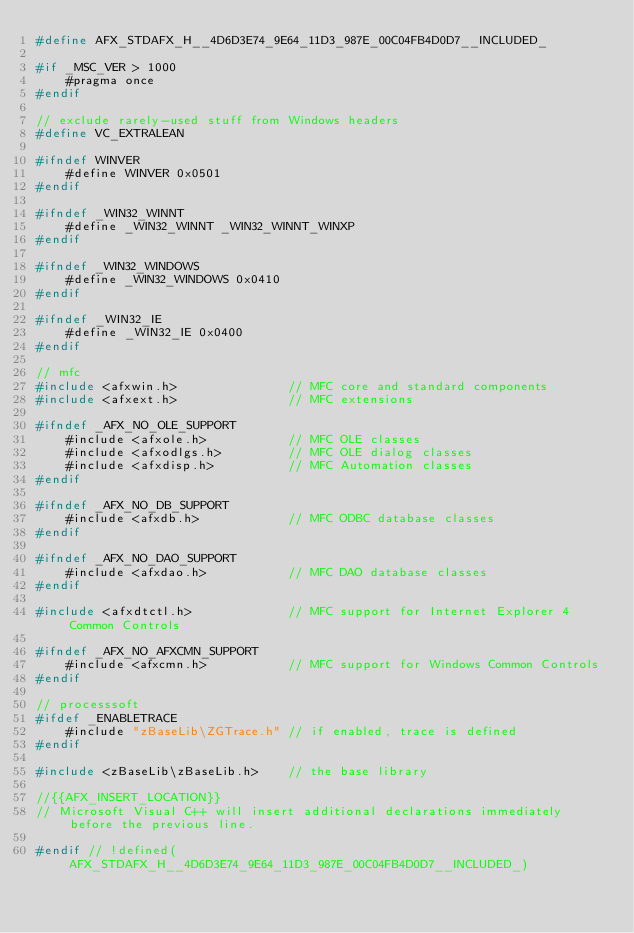Convert code to text. <code><loc_0><loc_0><loc_500><loc_500><_C_>#define AFX_STDAFX_H__4D6D3E74_9E64_11D3_987E_00C04FB4D0D7__INCLUDED_

#if _MSC_VER > 1000
    #pragma once
#endif

// exclude rarely-used stuff from Windows headers
#define VC_EXTRALEAN

#ifndef WINVER
    #define WINVER 0x0501
#endif

#ifndef _WIN32_WINNT
    #define _WIN32_WINNT _WIN32_WINNT_WINXP
#endif

#ifndef _WIN32_WINDOWS
    #define _WIN32_WINDOWS 0x0410
#endif

#ifndef _WIN32_IE
    #define _WIN32_IE 0x0400
#endif

// mfc
#include <afxwin.h>               // MFC core and standard components
#include <afxext.h>               // MFC extensions

#ifndef _AFX_NO_OLE_SUPPORT
    #include <afxole.h>           // MFC OLE classes
    #include <afxodlgs.h>         // MFC OLE dialog classes
    #include <afxdisp.h>          // MFC Automation classes
#endif

#ifndef _AFX_NO_DB_SUPPORT
    #include <afxdb.h>            // MFC ODBC database classes
#endif

#ifndef _AFX_NO_DAO_SUPPORT
    #include <afxdao.h>           // MFC DAO database classes
#endif

#include <afxdtctl.h>             // MFC support for Internet Explorer 4 Common Controls

#ifndef _AFX_NO_AFXCMN_SUPPORT
    #include <afxcmn.h>           // MFC support for Windows Common Controls
#endif

// processsoft
#ifdef _ENABLETRACE
    #include "zBaseLib\ZGTrace.h" // if enabled, trace is defined
#endif

#include <zBaseLib\zBaseLib.h>    // the base library

//{{AFX_INSERT_LOCATION}}
// Microsoft Visual C++ will insert additional declarations immediately before the previous line.

#endif // !defined(AFX_STDAFX_H__4D6D3E74_9E64_11D3_987E_00C04FB4D0D7__INCLUDED_)
</code> 